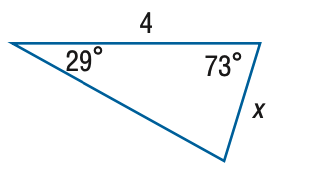Question: Find x. Round side measure to the nearest tenth.
Choices:
A. 2.0
B. 4.1
C. 7.9
D. 8.1
Answer with the letter. Answer: A 